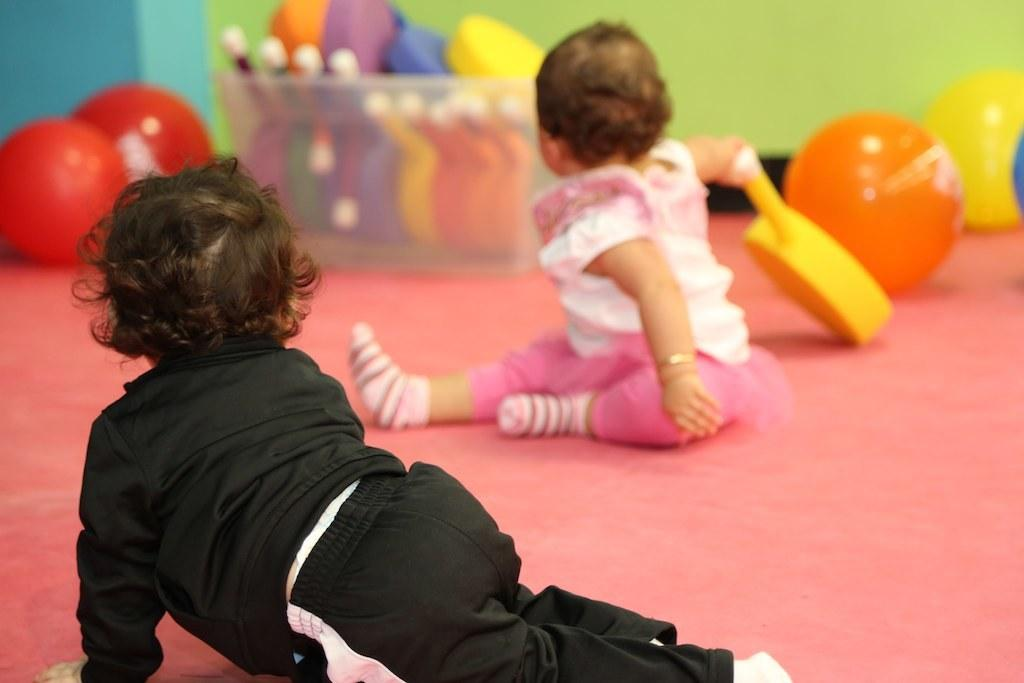What is located on the left side of the image? There is a baby on the left side of the image. What is the baby on the left side wearing? The baby on the left side is wearing a black dress. What is located on the right side of the image? There is another baby on the right side of the image. What is the baby on the right side wearing? The baby on the right side is wearing a white top. What type of disease is affecting the baby on the right side of the image? There is no indication of any disease affecting the baby in the image; both babies appear to be healthy. What type of power does the baby on the left side of the image possess? There is no mention of any supernatural powers in the image; the babies are simply wearing different colored clothing. 